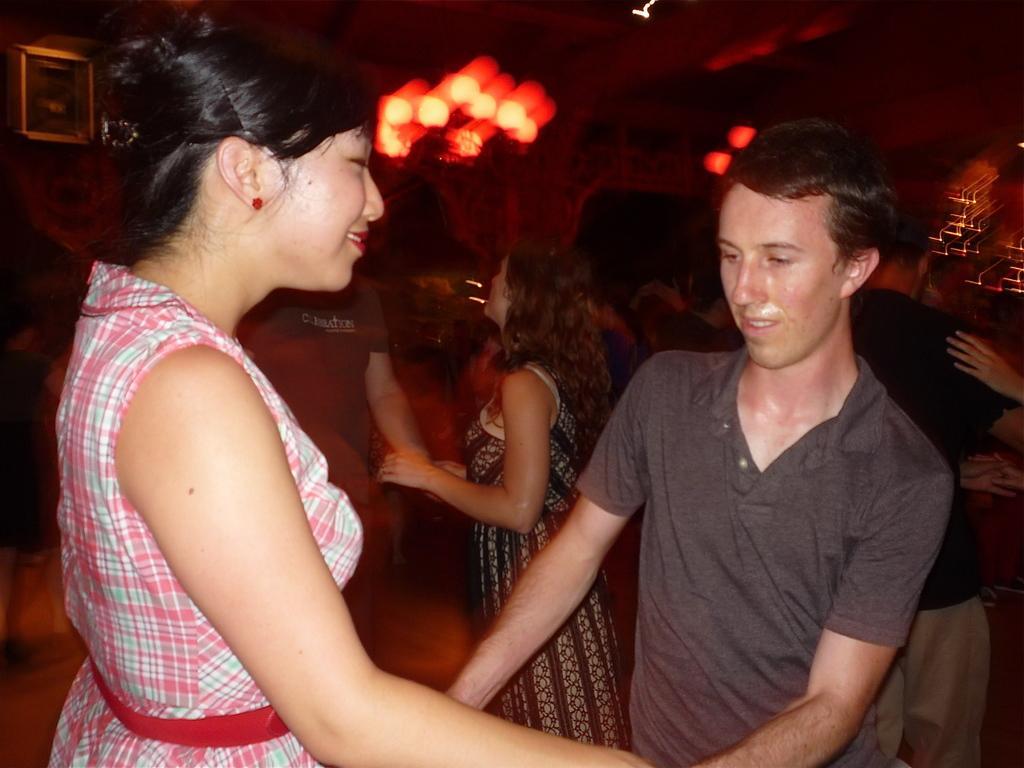Can you describe this image briefly? In this image there are people dancing, in the background it is blurred. 